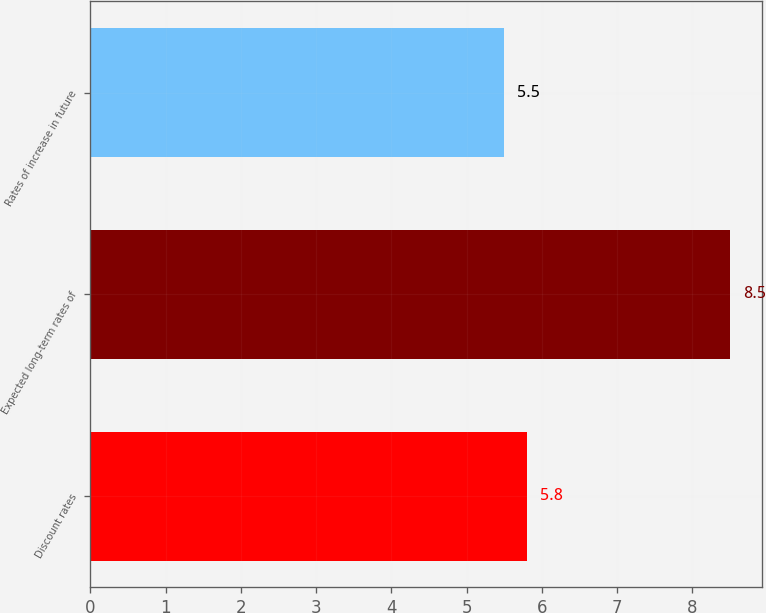Convert chart. <chart><loc_0><loc_0><loc_500><loc_500><bar_chart><fcel>Discount rates<fcel>Expected long-term rates of<fcel>Rates of increase in future<nl><fcel>5.8<fcel>8.5<fcel>5.5<nl></chart> 